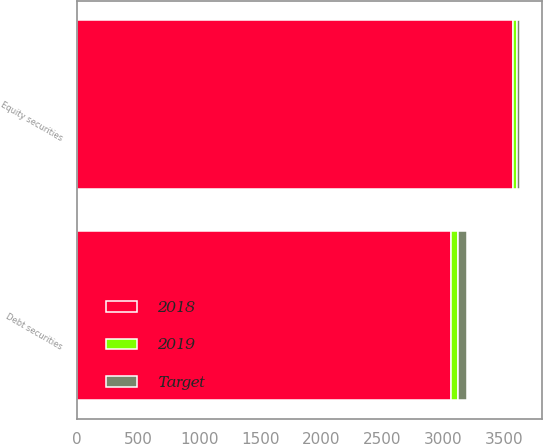Convert chart to OTSL. <chart><loc_0><loc_0><loc_500><loc_500><stacked_bar_chart><ecel><fcel>Equity securities<fcel>Debt securities<nl><fcel>2018<fcel>3570<fcel>3065<nl><fcel>2019<fcel>35.1<fcel>59.5<nl><fcel>Target<fcel>27.1<fcel>72.5<nl></chart> 